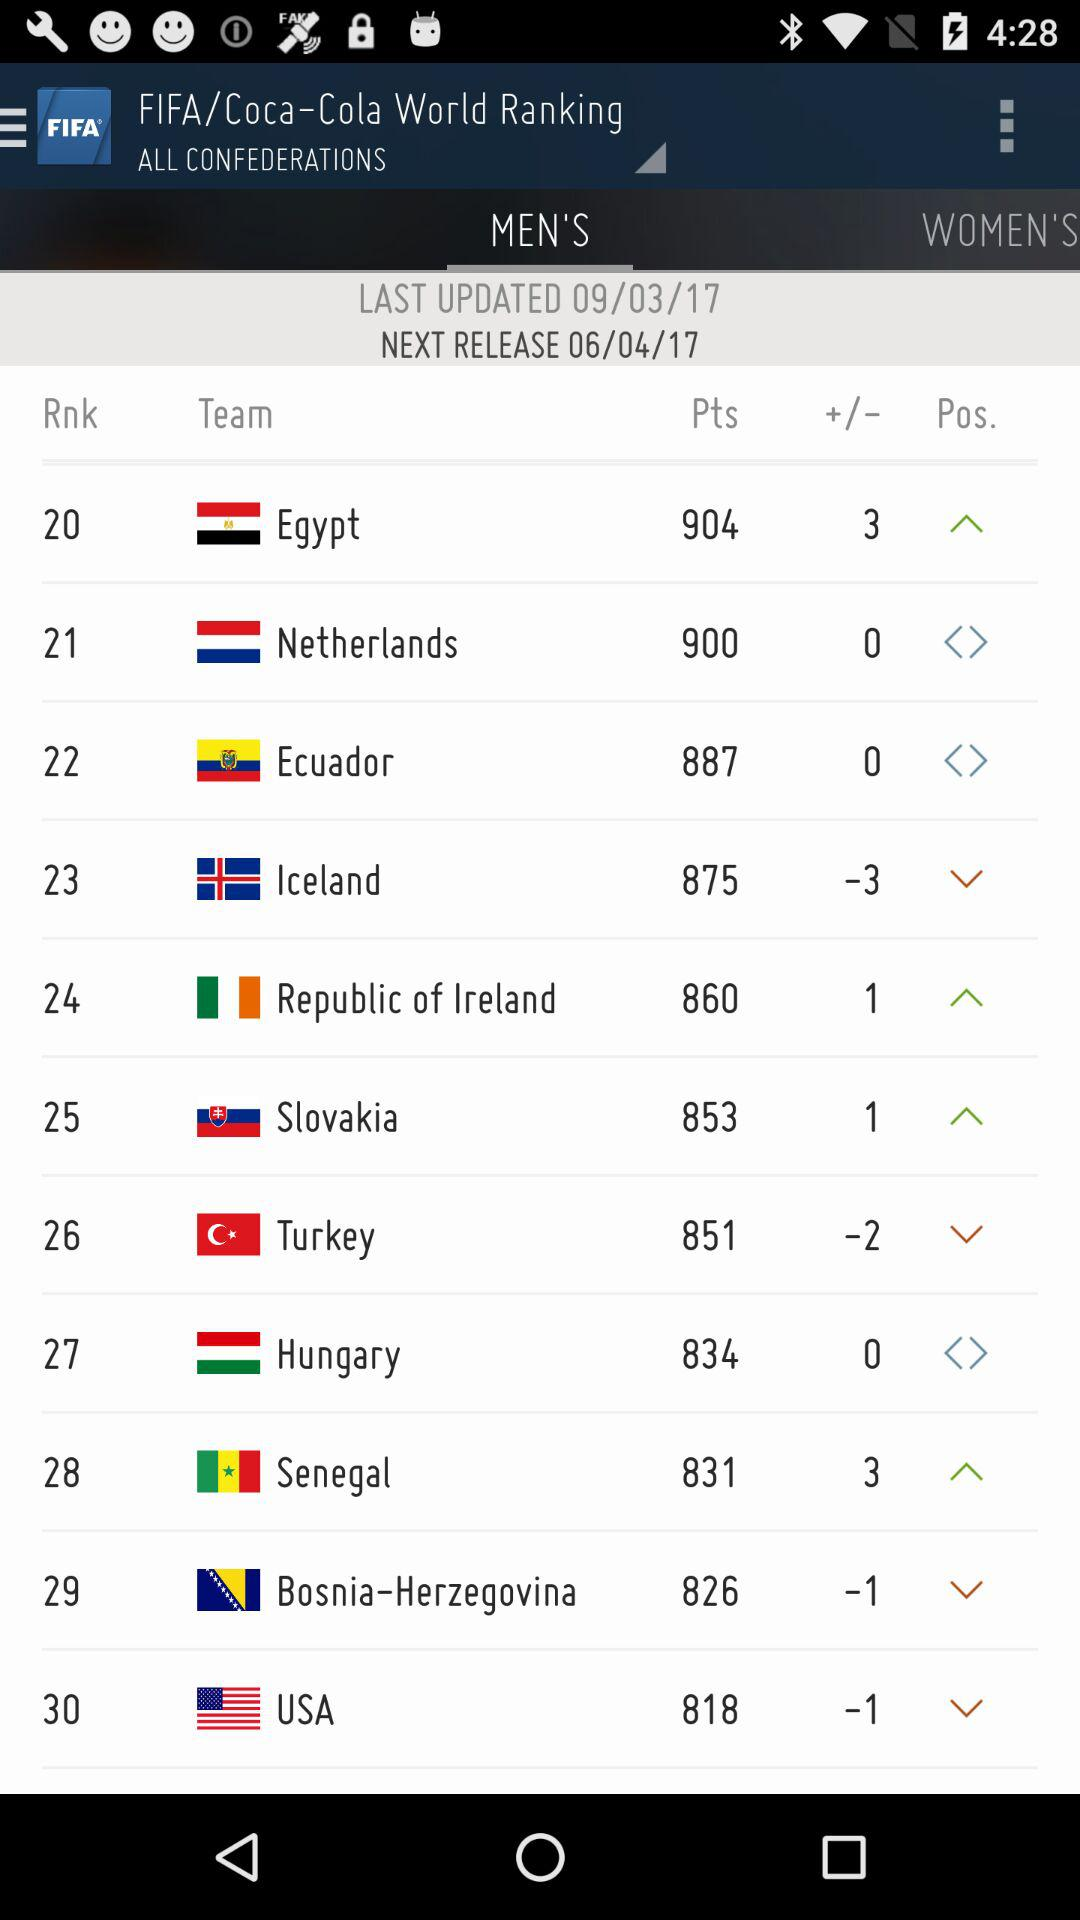Which option is selected for ranking?
When the provided information is insufficient, respond with <no answer>. <no answer> 